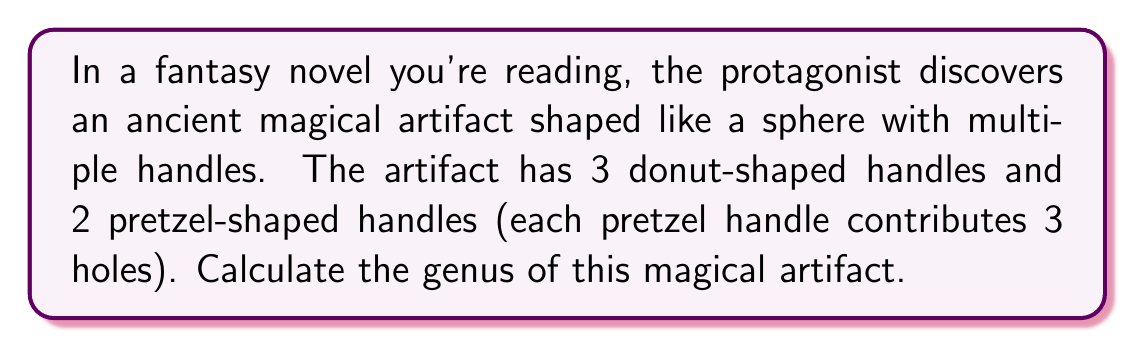Show me your answer to this math problem. To calculate the genus of this magical artifact, we need to understand a few key concepts from topology:

1. The genus of a surface is the maximum number of non-intersecting simple closed curves that can be drawn on the surface without separating it.

2. For a sphere, the genus is 0.

3. Each handle adds 1 to the genus of a surface.

4. A pretzel shape with 3 holes is topologically equivalent to a sphere with 3 handles.

Now, let's break down the problem:

1. Start with the base sphere: genus = 0

2. Add the donut-shaped handles:
   - Each donut-shaped handle adds 1 to the genus
   - There are 3 donut-shaped handles
   - Contribution to genus: $3 \times 1 = 3$

3. Add the pretzel-shaped handles:
   - Each pretzel-shaped handle is equivalent to 3 handles
   - There are 2 pretzel-shaped handles
   - Contribution to genus: $2 \times 3 = 6$

4. Calculate the total genus:
   $$\text{Total genus} = \text{Base genus} + \text{Donut handles} + \text{Pretzel handles}$$
   $$\text{Total genus} = 0 + 3 + 6 = 9$$

Therefore, the genus of the magical artifact is 9.
Answer: The genus of the magical artifact is 9. 